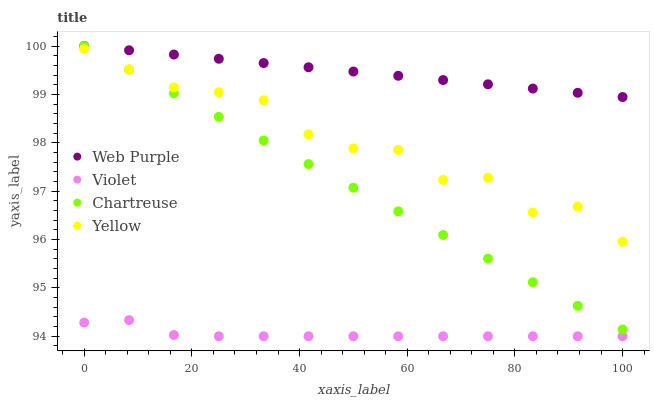Does Violet have the minimum area under the curve?
Answer yes or no. Yes. Does Web Purple have the maximum area under the curve?
Answer yes or no. Yes. Does Chartreuse have the minimum area under the curve?
Answer yes or no. No. Does Chartreuse have the maximum area under the curve?
Answer yes or no. No. Is Web Purple the smoothest?
Answer yes or no. Yes. Is Yellow the roughest?
Answer yes or no. Yes. Is Chartreuse the smoothest?
Answer yes or no. No. Is Chartreuse the roughest?
Answer yes or no. No. Does Violet have the lowest value?
Answer yes or no. Yes. Does Chartreuse have the lowest value?
Answer yes or no. No. Does Chartreuse have the highest value?
Answer yes or no. Yes. Does Yellow have the highest value?
Answer yes or no. No. Is Violet less than Chartreuse?
Answer yes or no. Yes. Is Web Purple greater than Yellow?
Answer yes or no. Yes. Does Chartreuse intersect Web Purple?
Answer yes or no. Yes. Is Chartreuse less than Web Purple?
Answer yes or no. No. Is Chartreuse greater than Web Purple?
Answer yes or no. No. Does Violet intersect Chartreuse?
Answer yes or no. No. 